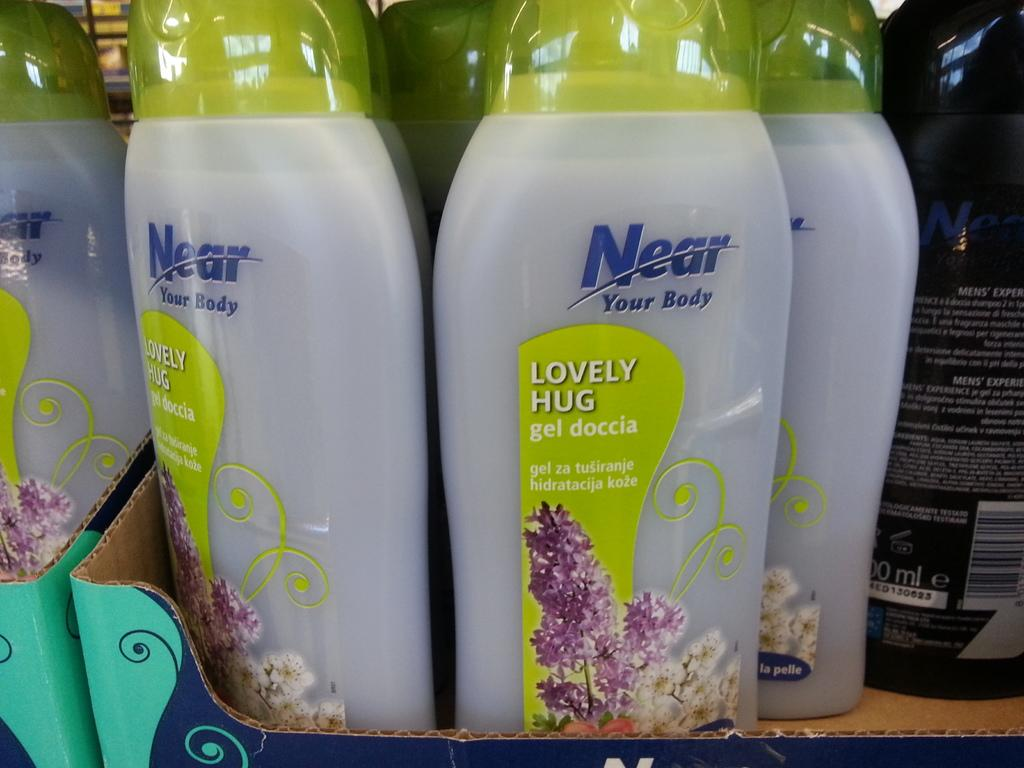Provide a one-sentence caption for the provided image. A box display of Near Your Body soap with lavender on the label. 